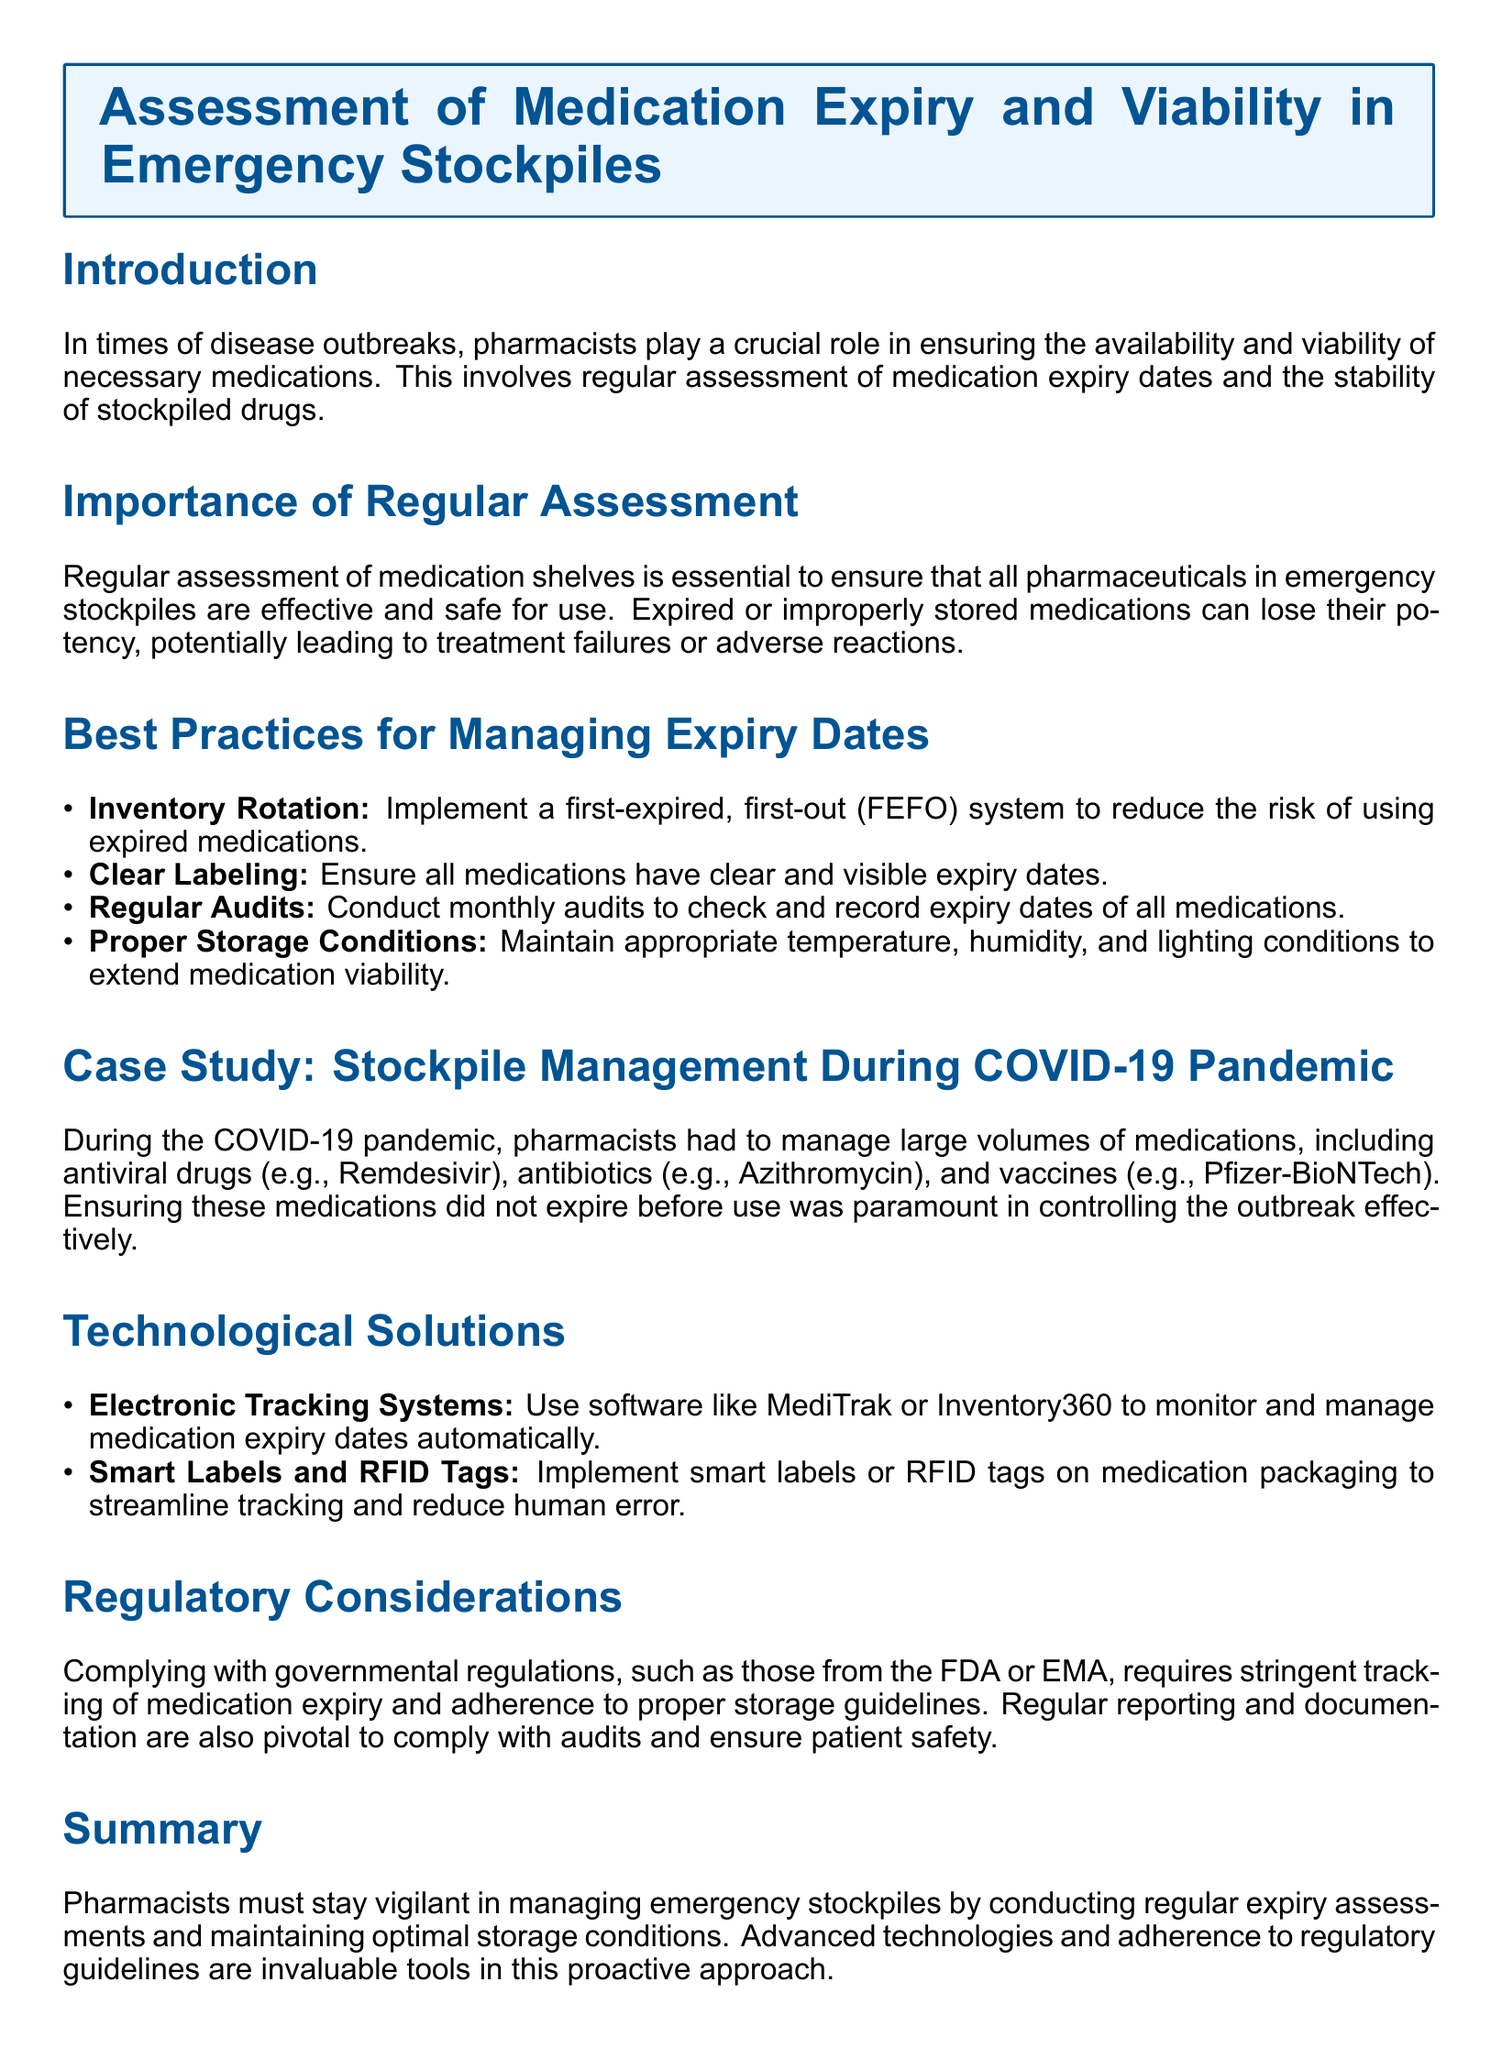What is the title of the document? The title of the document is highlighted at the beginning and provides the focus of the assessment.
Answer: Assessment of Medication Expiry and Viability in Emergency Stockpiles What does FEFO stand for? FEFO is an abbreviation used in the document for a system that helps in managing medications effectively.
Answer: First-Expired, First-Out How often should audits be conducted? The document specifies the frequency of audits in relation to medication expiry assessments.
Answer: Monthly Which antiviral drug is mentioned as part of the COVID-19 pandemic stockpile management? The document discusses specific medications during the COVID-19 pandemic along with their types.
Answer: Remdesivir What are two technological solutions mentioned in the document? The document outlines technological approaches to enhance medication tracking and management.
Answer: Electronic Tracking Systems and Smart Labels Why is regular assessment of medications essential? The document highlights the significance of assessing medications concerning their effectiveness and safety.
Answer: To ensure effectiveness and safety What is one regulatory aspect emphasized in the document? The document mentions compliance with governmental regulations as a critical part of medication management.
Answer: Adherence to proper storage guidelines Which medication type is highlighted as needing management during outbreaks? The document identifies different categories of medications that require careful oversight during emergencies.
Answer: Vaccines What color is used for the header box in the document? The document mentions the color scheme used for the header box that organizes the content visually.
Answer: Light Blue 